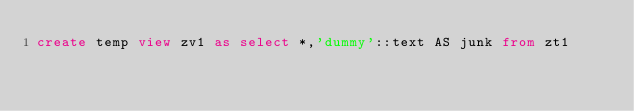Convert code to text. <code><loc_0><loc_0><loc_500><loc_500><_SQL_>create temp view zv1 as select *,'dummy'::text AS junk from zt1
</code> 